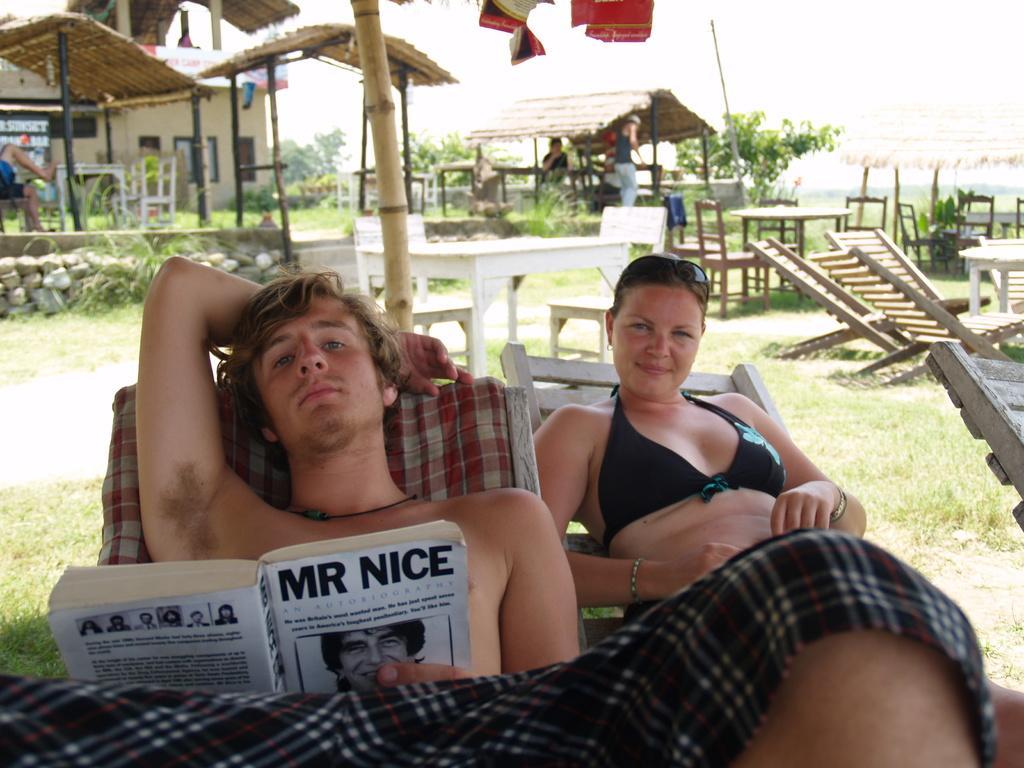Please provide a concise description of this image. In this image I can see a man and a woman are lying on chairs. The man is holding a book in the hand. In the background I can see a house, tables, chairs, the grass, plants and some other objects on the ground. 